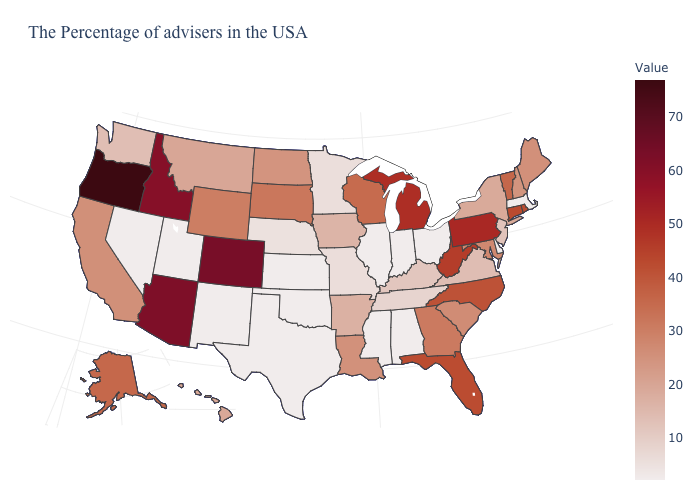Does Montana have the highest value in the West?
Short answer required. No. Does the map have missing data?
Be succinct. No. Does the map have missing data?
Be succinct. No. 